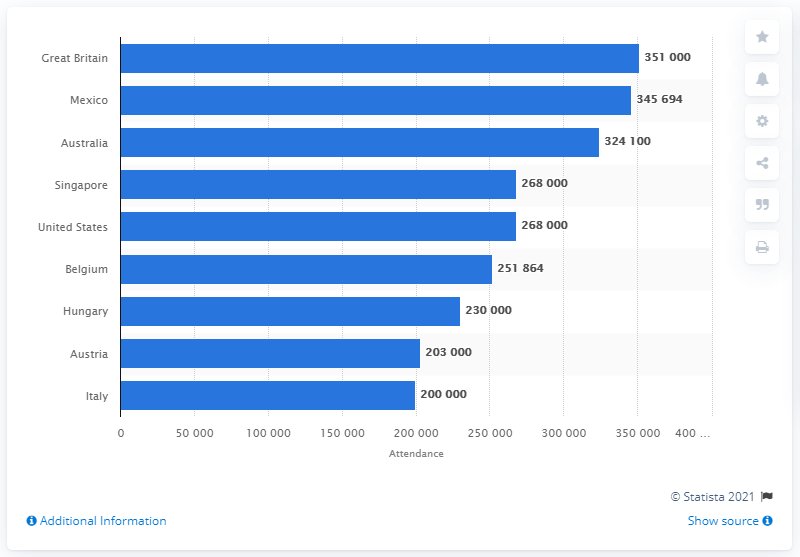Highlight a few significant elements in this photo. In 2019, the British Grand Prix in Silverstone attracted a total of 351,000 spectators, demonstrating the popularity of the event among fans. 